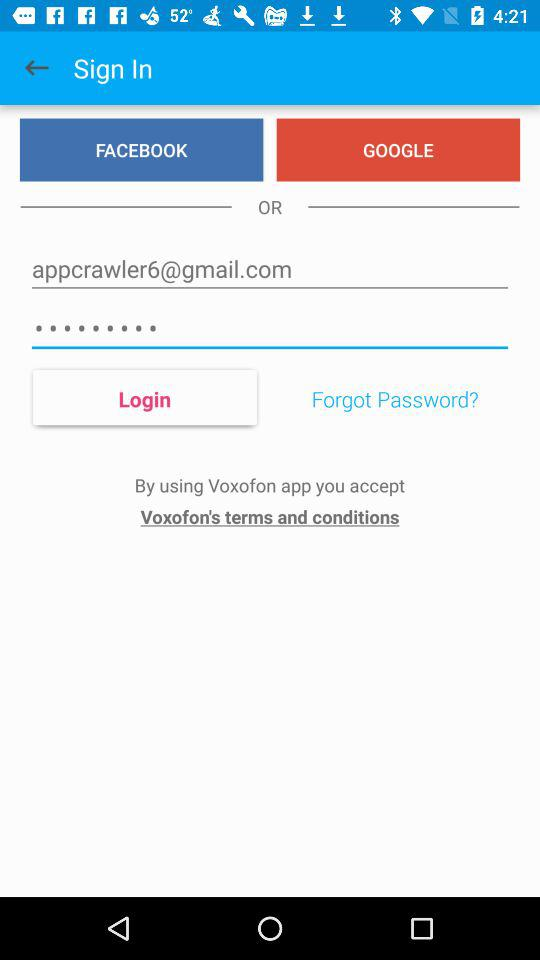Through which accounts can sign in be done? You can sign in with Facebook and Google. 